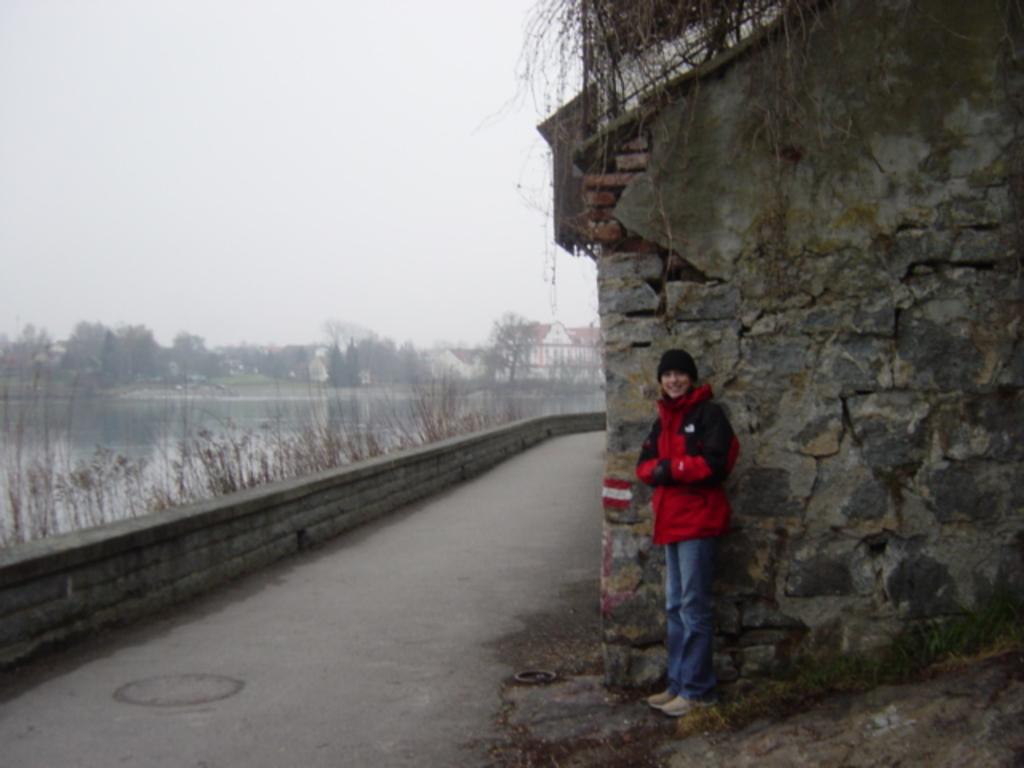Could you give a brief overview of what you see in this image? In this image I can see the person standing and the person is wearing red and blue color dress. In the background I can see the water, few trees, buildings and the sky is in white color. 